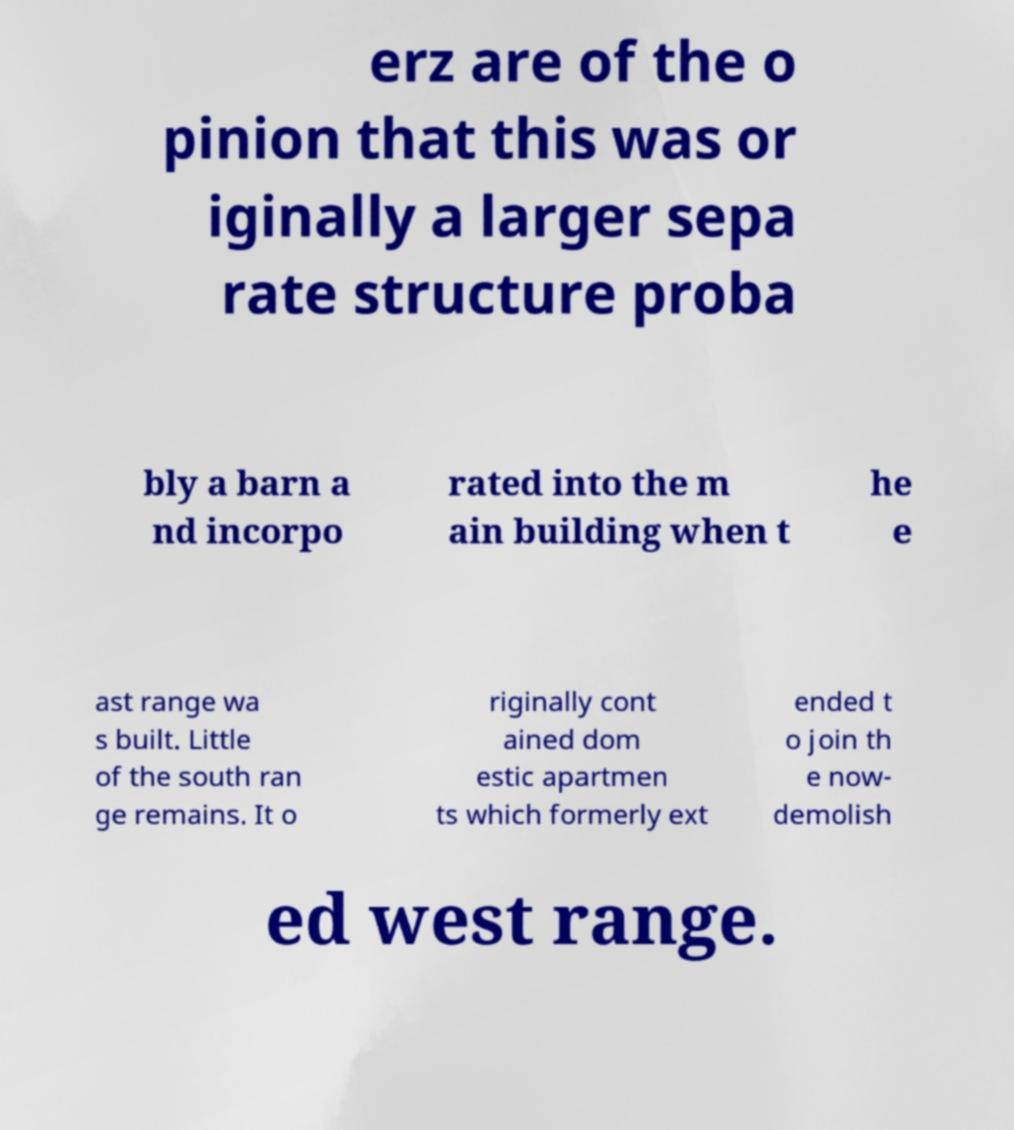I need the written content from this picture converted into text. Can you do that? erz are of the o pinion that this was or iginally a larger sepa rate structure proba bly a barn a nd incorpo rated into the m ain building when t he e ast range wa s built. Little of the south ran ge remains. It o riginally cont ained dom estic apartmen ts which formerly ext ended t o join th e now- demolish ed west range. 